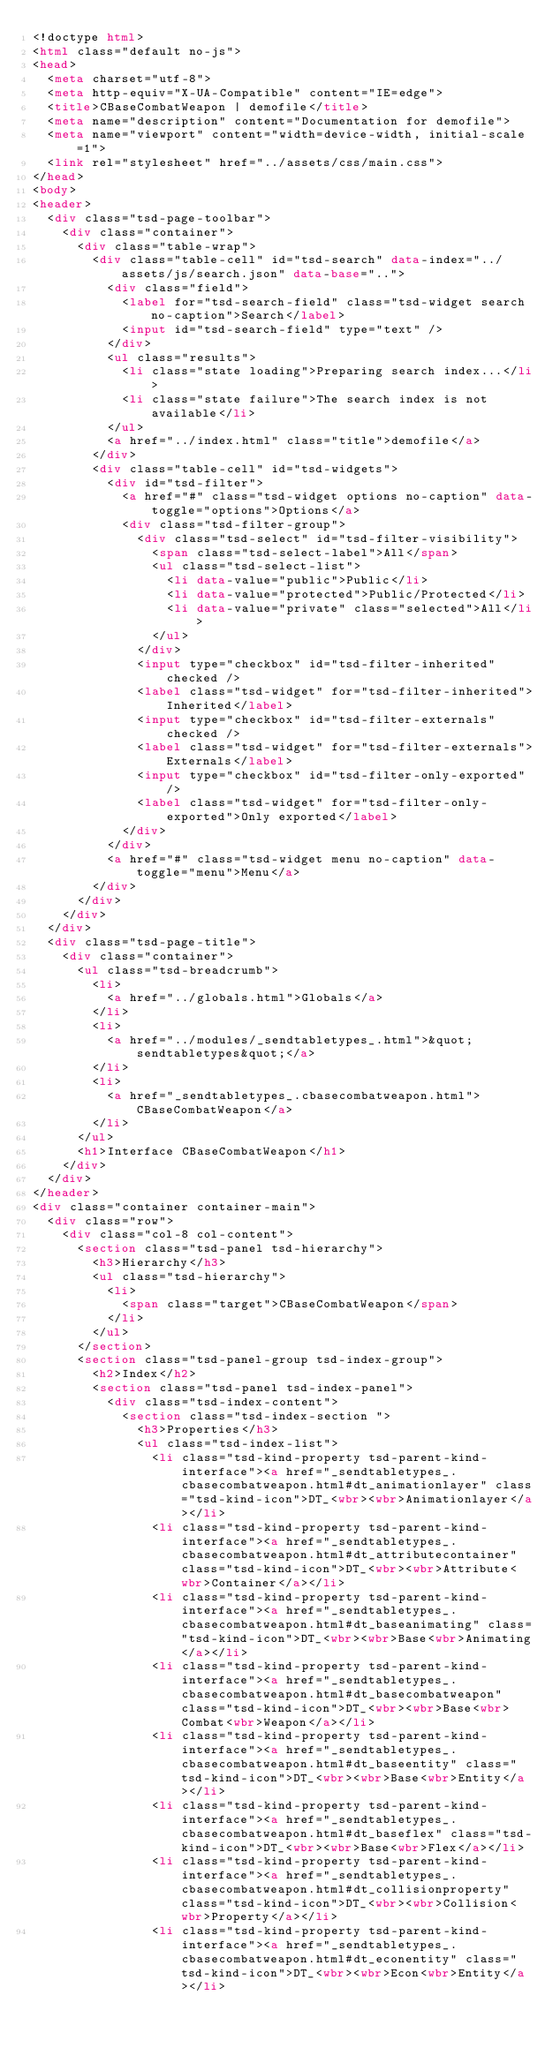Convert code to text. <code><loc_0><loc_0><loc_500><loc_500><_HTML_><!doctype html>
<html class="default no-js">
<head>
	<meta charset="utf-8">
	<meta http-equiv="X-UA-Compatible" content="IE=edge">
	<title>CBaseCombatWeapon | demofile</title>
	<meta name="description" content="Documentation for demofile">
	<meta name="viewport" content="width=device-width, initial-scale=1">
	<link rel="stylesheet" href="../assets/css/main.css">
</head>
<body>
<header>
	<div class="tsd-page-toolbar">
		<div class="container">
			<div class="table-wrap">
				<div class="table-cell" id="tsd-search" data-index="../assets/js/search.json" data-base="..">
					<div class="field">
						<label for="tsd-search-field" class="tsd-widget search no-caption">Search</label>
						<input id="tsd-search-field" type="text" />
					</div>
					<ul class="results">
						<li class="state loading">Preparing search index...</li>
						<li class="state failure">The search index is not available</li>
					</ul>
					<a href="../index.html" class="title">demofile</a>
				</div>
				<div class="table-cell" id="tsd-widgets">
					<div id="tsd-filter">
						<a href="#" class="tsd-widget options no-caption" data-toggle="options">Options</a>
						<div class="tsd-filter-group">
							<div class="tsd-select" id="tsd-filter-visibility">
								<span class="tsd-select-label">All</span>
								<ul class="tsd-select-list">
									<li data-value="public">Public</li>
									<li data-value="protected">Public/Protected</li>
									<li data-value="private" class="selected">All</li>
								</ul>
							</div>
							<input type="checkbox" id="tsd-filter-inherited" checked />
							<label class="tsd-widget" for="tsd-filter-inherited">Inherited</label>
							<input type="checkbox" id="tsd-filter-externals" checked />
							<label class="tsd-widget" for="tsd-filter-externals">Externals</label>
							<input type="checkbox" id="tsd-filter-only-exported" />
							<label class="tsd-widget" for="tsd-filter-only-exported">Only exported</label>
						</div>
					</div>
					<a href="#" class="tsd-widget menu no-caption" data-toggle="menu">Menu</a>
				</div>
			</div>
		</div>
	</div>
	<div class="tsd-page-title">
		<div class="container">
			<ul class="tsd-breadcrumb">
				<li>
					<a href="../globals.html">Globals</a>
				</li>
				<li>
					<a href="../modules/_sendtabletypes_.html">&quot;sendtabletypes&quot;</a>
				</li>
				<li>
					<a href="_sendtabletypes_.cbasecombatweapon.html">CBaseCombatWeapon</a>
				</li>
			</ul>
			<h1>Interface CBaseCombatWeapon</h1>
		</div>
	</div>
</header>
<div class="container container-main">
	<div class="row">
		<div class="col-8 col-content">
			<section class="tsd-panel tsd-hierarchy">
				<h3>Hierarchy</h3>
				<ul class="tsd-hierarchy">
					<li>
						<span class="target">CBaseCombatWeapon</span>
					</li>
				</ul>
			</section>
			<section class="tsd-panel-group tsd-index-group">
				<h2>Index</h2>
				<section class="tsd-panel tsd-index-panel">
					<div class="tsd-index-content">
						<section class="tsd-index-section ">
							<h3>Properties</h3>
							<ul class="tsd-index-list">
								<li class="tsd-kind-property tsd-parent-kind-interface"><a href="_sendtabletypes_.cbasecombatweapon.html#dt_animationlayer" class="tsd-kind-icon">DT_<wbr><wbr>Animationlayer</a></li>
								<li class="tsd-kind-property tsd-parent-kind-interface"><a href="_sendtabletypes_.cbasecombatweapon.html#dt_attributecontainer" class="tsd-kind-icon">DT_<wbr><wbr>Attribute<wbr>Container</a></li>
								<li class="tsd-kind-property tsd-parent-kind-interface"><a href="_sendtabletypes_.cbasecombatweapon.html#dt_baseanimating" class="tsd-kind-icon">DT_<wbr><wbr>Base<wbr>Animating</a></li>
								<li class="tsd-kind-property tsd-parent-kind-interface"><a href="_sendtabletypes_.cbasecombatweapon.html#dt_basecombatweapon" class="tsd-kind-icon">DT_<wbr><wbr>Base<wbr>Combat<wbr>Weapon</a></li>
								<li class="tsd-kind-property tsd-parent-kind-interface"><a href="_sendtabletypes_.cbasecombatweapon.html#dt_baseentity" class="tsd-kind-icon">DT_<wbr><wbr>Base<wbr>Entity</a></li>
								<li class="tsd-kind-property tsd-parent-kind-interface"><a href="_sendtabletypes_.cbasecombatweapon.html#dt_baseflex" class="tsd-kind-icon">DT_<wbr><wbr>Base<wbr>Flex</a></li>
								<li class="tsd-kind-property tsd-parent-kind-interface"><a href="_sendtabletypes_.cbasecombatweapon.html#dt_collisionproperty" class="tsd-kind-icon">DT_<wbr><wbr>Collision<wbr>Property</a></li>
								<li class="tsd-kind-property tsd-parent-kind-interface"><a href="_sendtabletypes_.cbasecombatweapon.html#dt_econentity" class="tsd-kind-icon">DT_<wbr><wbr>Econ<wbr>Entity</a></li></code> 